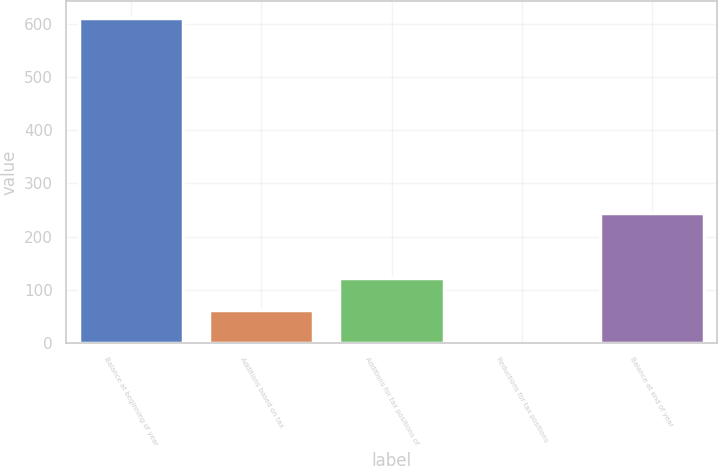Convert chart. <chart><loc_0><loc_0><loc_500><loc_500><bar_chart><fcel>Balance at beginning of year<fcel>Additions based on tax<fcel>Additions for tax positions of<fcel>Reductions for tax positions<fcel>Balance at end of year<nl><fcel>611.9<fcel>61.64<fcel>122.78<fcel>0.5<fcel>245.06<nl></chart> 